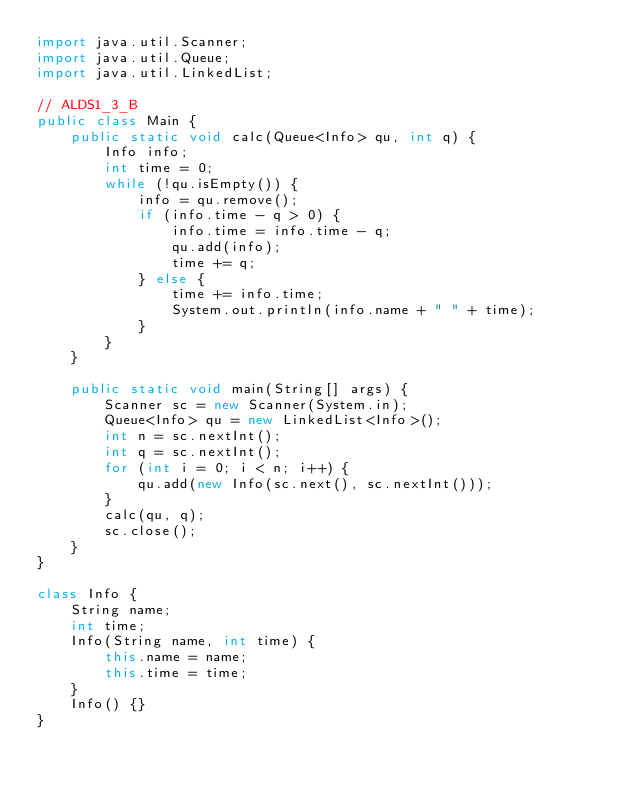<code> <loc_0><loc_0><loc_500><loc_500><_Java_>import java.util.Scanner;
import java.util.Queue;
import java.util.LinkedList;

// ALDS1_3_B
public class Main {
	public static void calc(Queue<Info> qu, int q) {
		Info info;
		int time = 0;
		while (!qu.isEmpty()) {
			info = qu.remove();
			if (info.time - q > 0) {
				info.time = info.time - q;
				qu.add(info);
				time += q;
			} else {
				time += info.time;
				System.out.println(info.name + " " + time);
			}
		}
	}
	
	public static void main(String[] args) {
		Scanner sc = new Scanner(System.in);
		Queue<Info> qu = new LinkedList<Info>();
		int n = sc.nextInt();
		int q = sc.nextInt();
		for (int i = 0; i < n; i++) {
			qu.add(new Info(sc.next(), sc.nextInt()));
		}
		calc(qu, q);
		sc.close();
	}
}

class Info {
	String name;
	int time;
	Info(String name, int time) {
		this.name = name;
		this.time = time;
	}
	Info() {}
}
</code> 